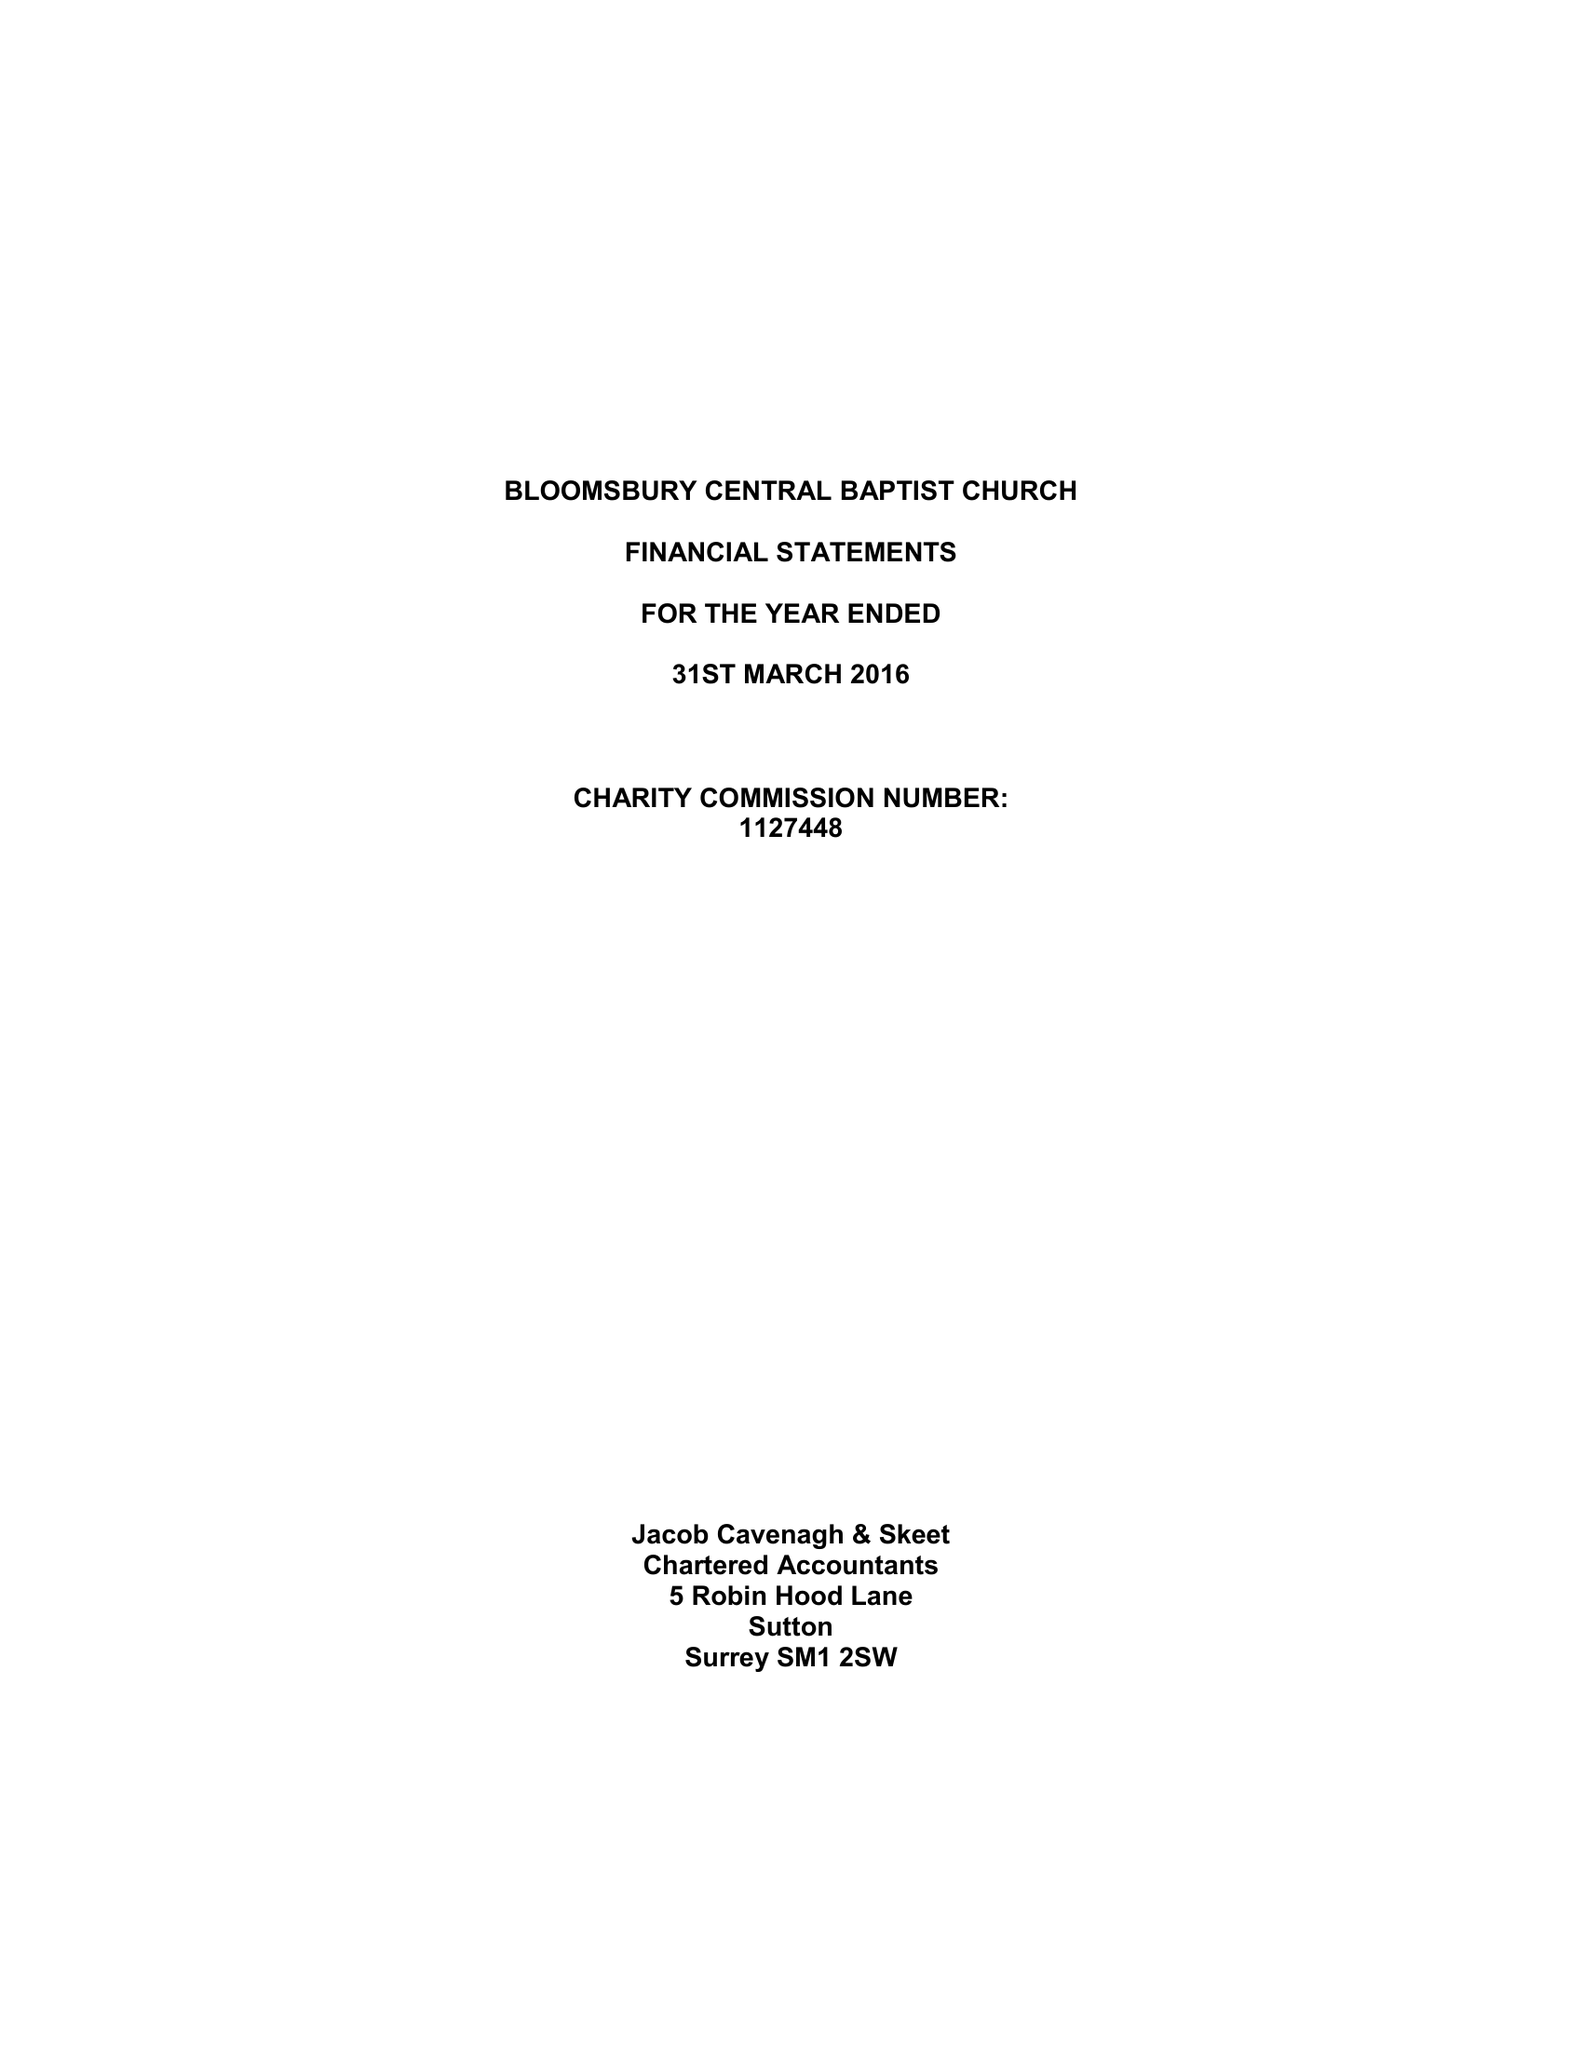What is the value for the address__postcode?
Answer the question using a single word or phrase. WC2H 8EP 